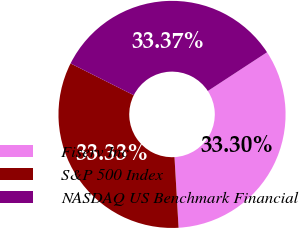Convert chart. <chart><loc_0><loc_0><loc_500><loc_500><pie_chart><fcel>Fiserv Inc<fcel>S&P 500 Index<fcel>NASDAQ US Benchmark Financial<nl><fcel>33.3%<fcel>33.33%<fcel>33.37%<nl></chart> 